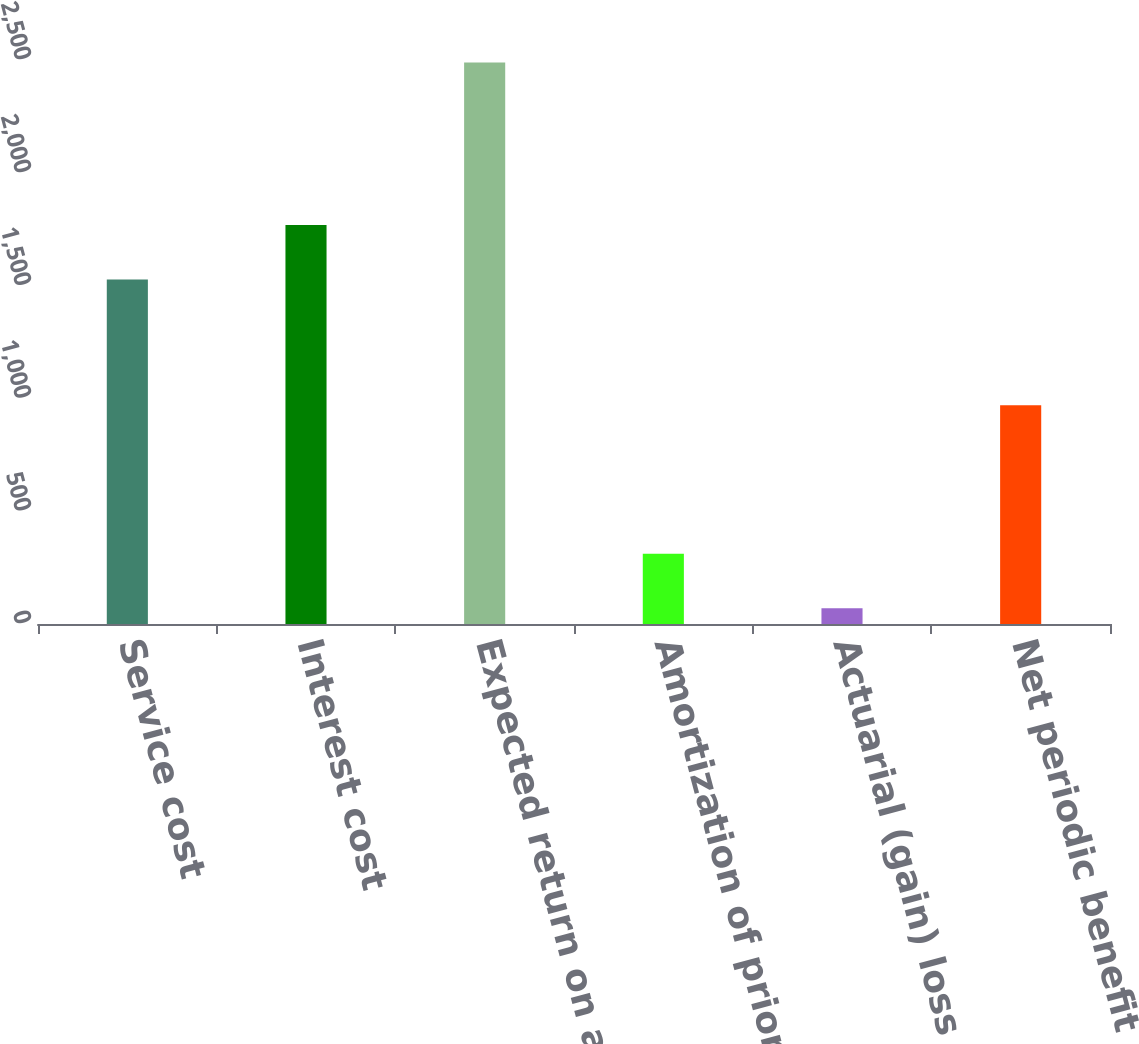<chart> <loc_0><loc_0><loc_500><loc_500><bar_chart><fcel>Service cost<fcel>Interest cost<fcel>Expected return on assets<fcel>Amortization of prior service<fcel>Actuarial (gain) loss<fcel>Net periodic benefit cost<nl><fcel>1527<fcel>1768.9<fcel>2489<fcel>311.9<fcel>70<fcel>970<nl></chart> 